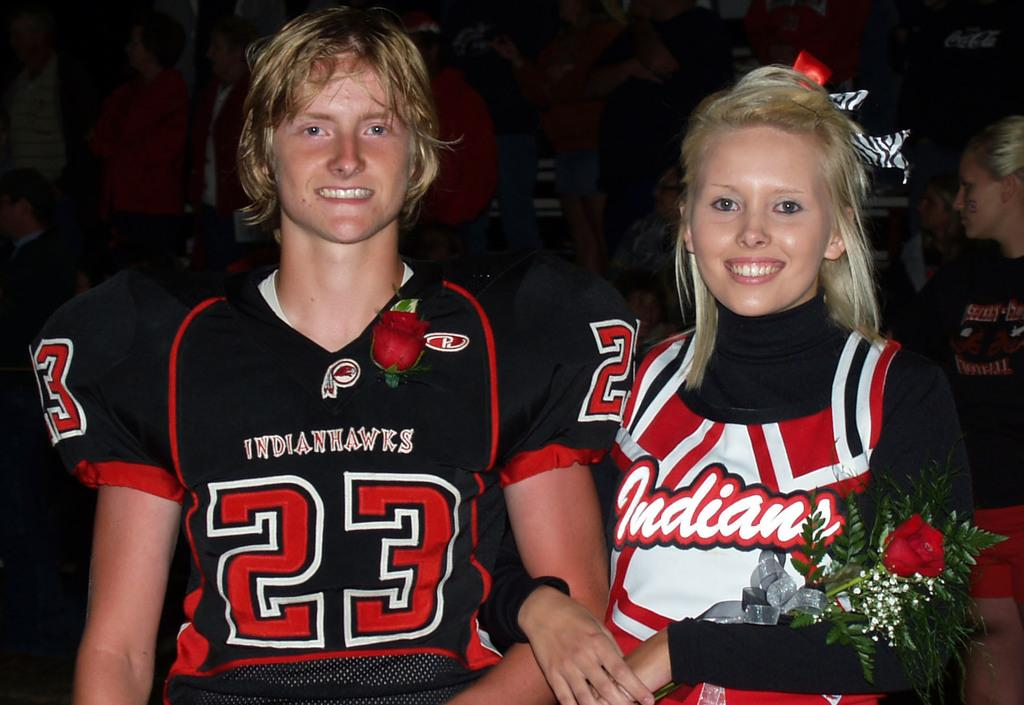<image>
Present a compact description of the photo's key features. Football player waering number 23 posing with a woman holding a rose. 